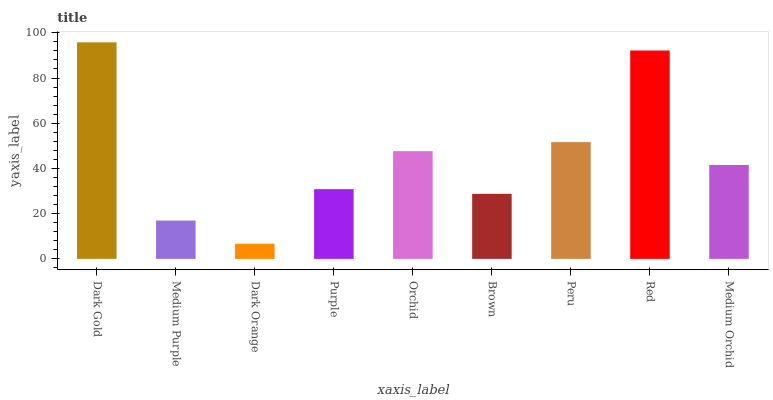Is Dark Orange the minimum?
Answer yes or no. Yes. Is Dark Gold the maximum?
Answer yes or no. Yes. Is Medium Purple the minimum?
Answer yes or no. No. Is Medium Purple the maximum?
Answer yes or no. No. Is Dark Gold greater than Medium Purple?
Answer yes or no. Yes. Is Medium Purple less than Dark Gold?
Answer yes or no. Yes. Is Medium Purple greater than Dark Gold?
Answer yes or no. No. Is Dark Gold less than Medium Purple?
Answer yes or no. No. Is Medium Orchid the high median?
Answer yes or no. Yes. Is Medium Orchid the low median?
Answer yes or no. Yes. Is Purple the high median?
Answer yes or no. No. Is Red the low median?
Answer yes or no. No. 